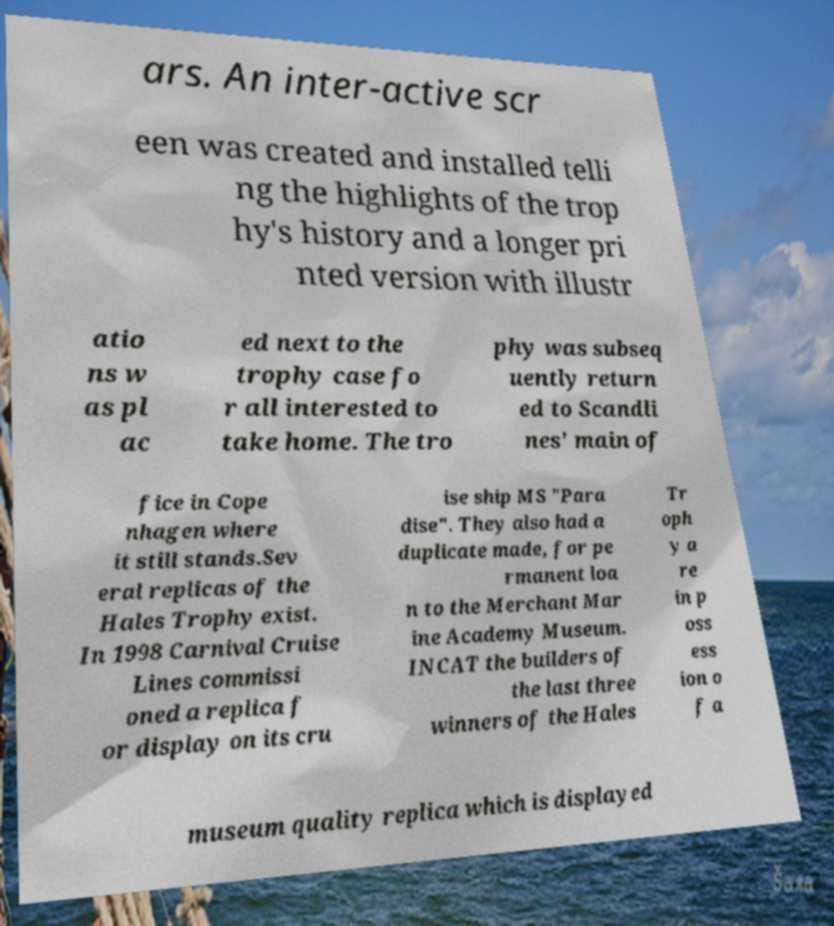Can you read and provide the text displayed in the image?This photo seems to have some interesting text. Can you extract and type it out for me? ars. An inter-active scr een was created and installed telli ng the highlights of the trop hy's history and a longer pri nted version with illustr atio ns w as pl ac ed next to the trophy case fo r all interested to take home. The tro phy was subseq uently return ed to Scandli nes' main of fice in Cope nhagen where it still stands.Sev eral replicas of the Hales Trophy exist. In 1998 Carnival Cruise Lines commissi oned a replica f or display on its cru ise ship MS "Para dise". They also had a duplicate made, for pe rmanent loa n to the Merchant Mar ine Academy Museum. INCAT the builders of the last three winners of the Hales Tr oph y a re in p oss ess ion o f a museum quality replica which is displayed 